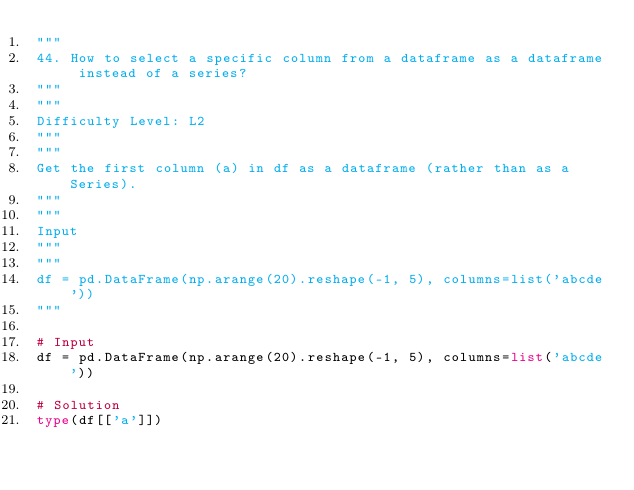Convert code to text. <code><loc_0><loc_0><loc_500><loc_500><_Python_>"""
44. How to select a specific column from a dataframe as a dataframe instead of a series?
"""
"""
Difficulty Level: L2
"""
"""
Get the first column (a) in df as a dataframe (rather than as a Series).
"""
"""
Input
"""
"""
df = pd.DataFrame(np.arange(20).reshape(-1, 5), columns=list('abcde'))
"""

# Input
df = pd.DataFrame(np.arange(20).reshape(-1, 5), columns=list('abcde'))

# Solution
type(df[['a']])</code> 